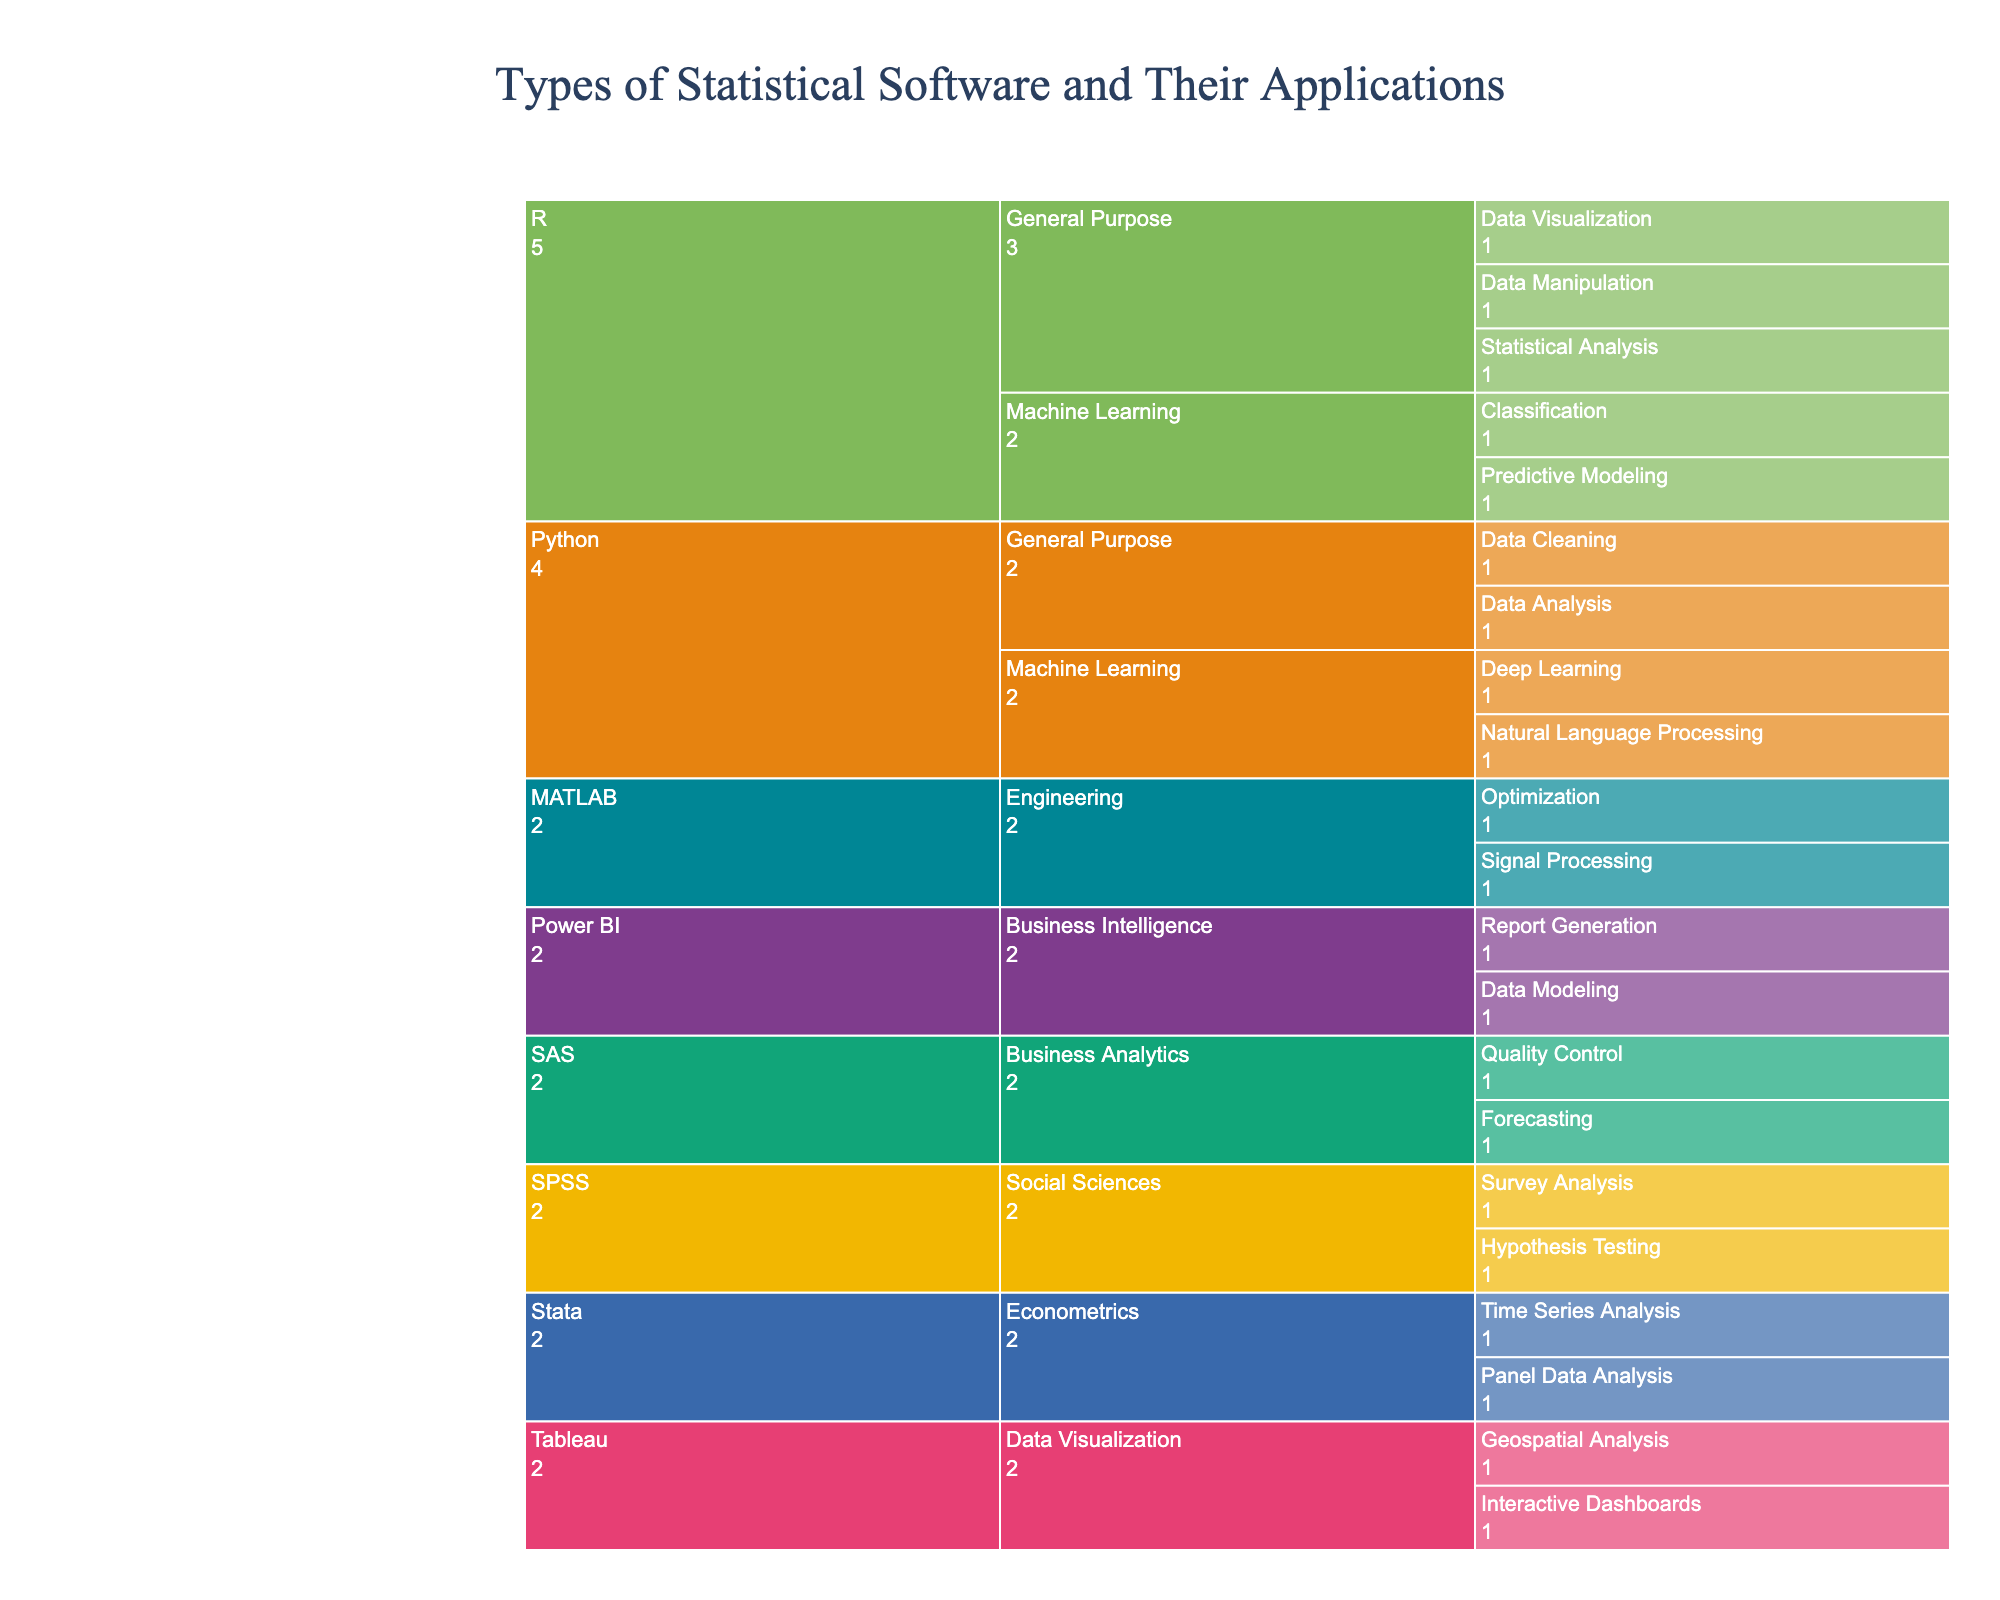What is the title of the figure? The title of the figure is usually placed at the top and it summarizes the subject of the visualization. In this case, it is "Types of Statistical Software and Their Applications".
Answer: Types of Statistical Software and Their Applications Which statistical software has the most categories listed? To find out which software has the most categories listed, we can count the number of subcategories directly under each software in the icicle chart. The software with the most categories is R.
Answer: R What categories are listed under SPSS and how many applications are there for each? To answer this, we look at the sections of the icicle chart under SPSS. The listed categories under SPSS are Social Sciences with two applications each (Survey Analysis and Hypothesis Testing).
Answer: Social Sciences - 2 (Survey Analysis, Hypothesis Testing) Which software has interactive dashboards as one of its applications? By scanning the applications listed under each software in the chart, we can find that Tableau has Interactive Dashboards as one of its applications.
Answer: Tableau Compare the applications of Python and MATLAB in terms of machine learning and engineering. For this, we break down the subcategories under Python and MATLAB. Python has machine learning applications such as Deep Learning and Natural Language Processing. MATLAB has engineering applications like Signal Processing and Optimization.
Answer: Python: Deep Learning, Natural Language Processing; MATLAB: Signal Processing, Optimization How many specific applications are there in total across all statistical software? To find the total number of specific applications, we count all the leaf nodes in the icicle chart. There are 20 specific applications in total.
Answer: 20 Which statistical software is used for both Business Analytics and Business Intelligence? By looking at the categories and their corresponding software, we see that SAS is used for Business Analytics and Power BI is used for Business Intelligence, but no single software is used for both.
Answer: None Which statistical software focuses on econometrics, and what are the key applications? We look at the sections under each software. The software focusing on econometrics is Stata, with key applications being Panel Data Analysis and Time Series Analysis.
Answer: Stata: Panel Data Analysis, Time Series Analysis 